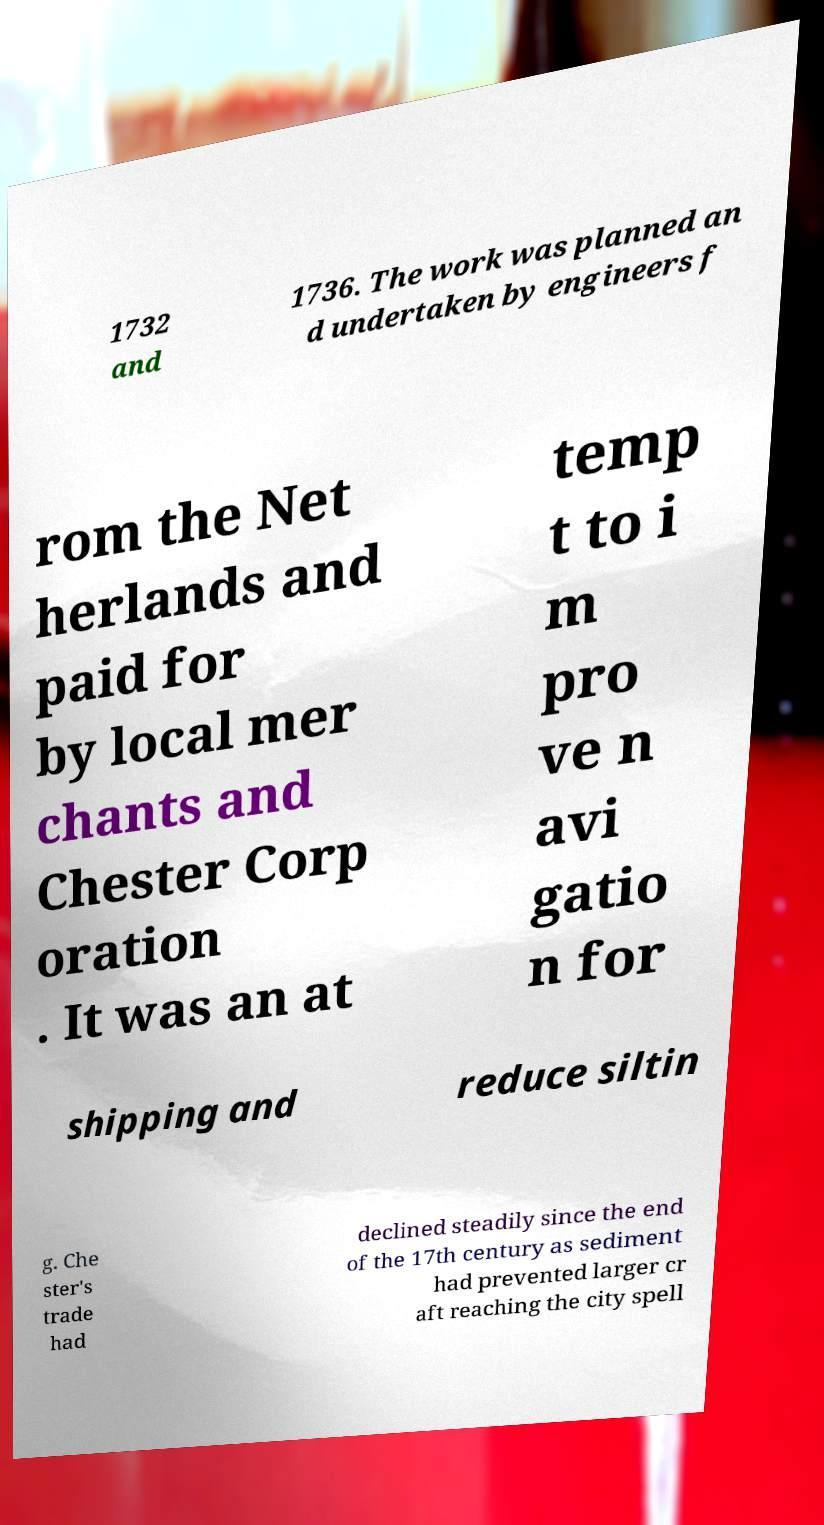For documentation purposes, I need the text within this image transcribed. Could you provide that? 1732 and 1736. The work was planned an d undertaken by engineers f rom the Net herlands and paid for by local mer chants and Chester Corp oration . It was an at temp t to i m pro ve n avi gatio n for shipping and reduce siltin g. Che ster's trade had declined steadily since the end of the 17th century as sediment had prevented larger cr aft reaching the city spell 